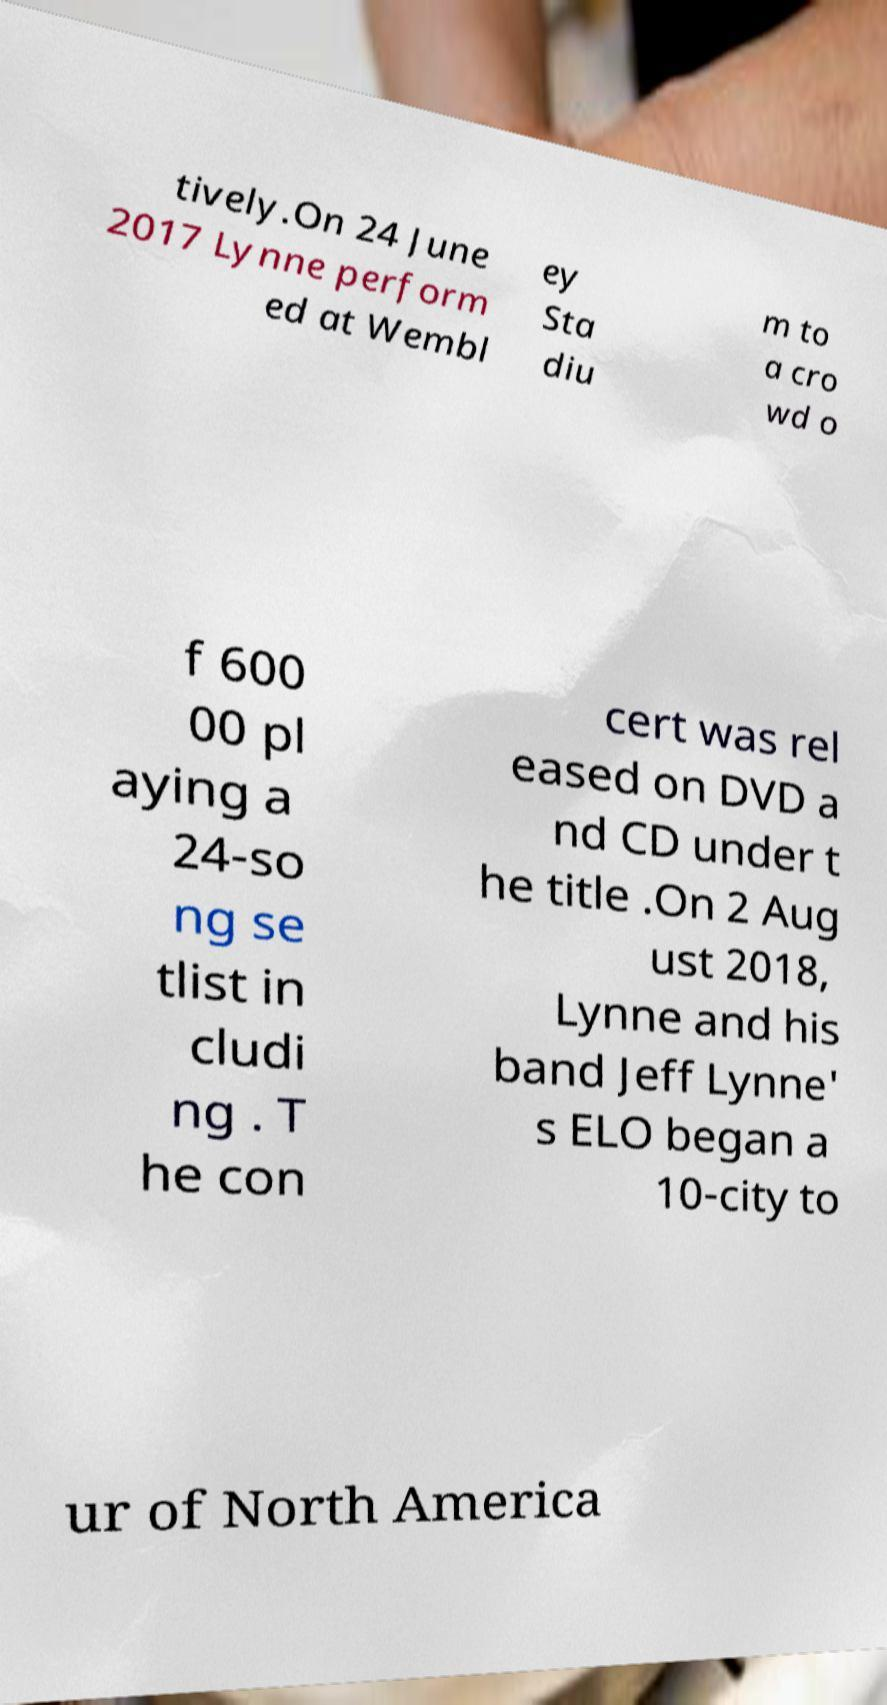Could you extract and type out the text from this image? tively.On 24 June 2017 Lynne perform ed at Wembl ey Sta diu m to a cro wd o f 600 00 pl aying a 24-so ng se tlist in cludi ng . T he con cert was rel eased on DVD a nd CD under t he title .On 2 Aug ust 2018, Lynne and his band Jeff Lynne' s ELO began a 10-city to ur of North America 